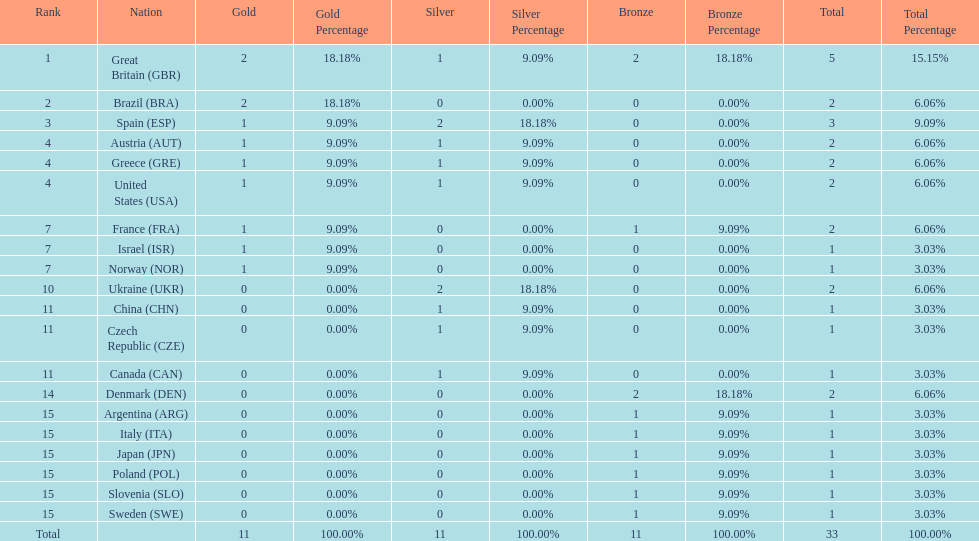What was the number of silver medals won by ukraine? 2. 